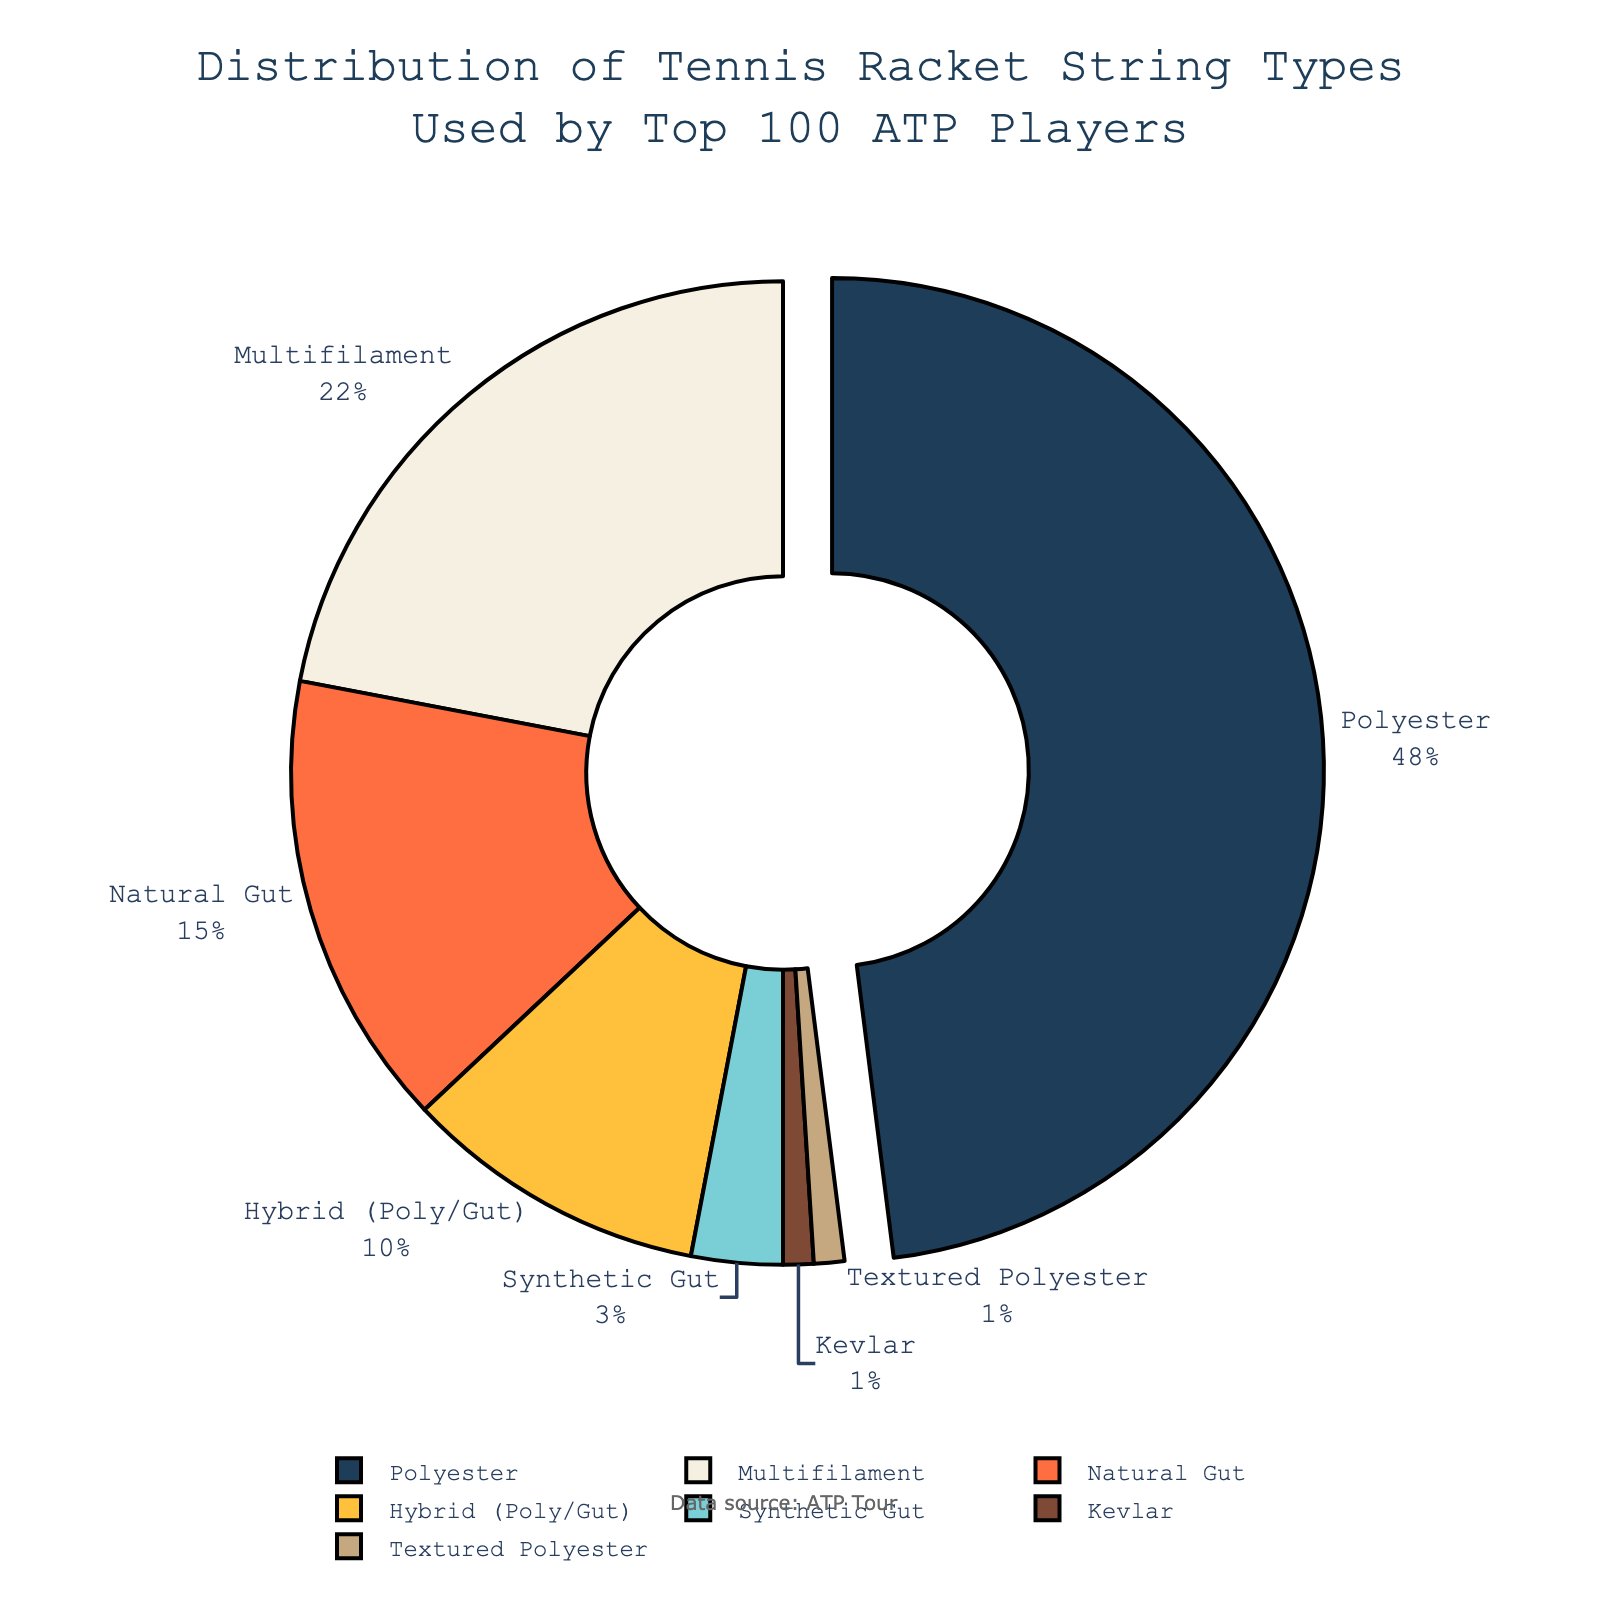Which string type has the highest percentage usage? The pie chart highlights the segment with the highest percentage usage. The chart also pulls this segment outward to make it more noticeable. The label shows that Polyester has the highest percentage at 48%.
Answer: Polyester What is the combined percentage of players using Hybrid and Synthetic Gut strings? To find the combined percentage, we add the percentage of players using Hybrid (10%) and the percentage using Synthetic Gut (3%). Therefore, 10 + 3 = 13%.
Answer: 13% How much more popular is Natural Gut compared to Synthetic Gut? To determine the difference in popularity, subtract the percentage of players using Synthetic Gut (3%) from those using Natural Gut (15%). Thus, 15 - 3 = 12%.
Answer: 12% Which string type has the least usage among top 100 ATP players? The pie chart shows the smallest segment labelled Textured Polyester, indicating it has the least usage at 1%.
Answer: Textured Polyester Compare the usage of Multifilament and Polyester strings: which one is more popular, and by how much in percentage points? Polyester is more popular than Multifilament. To find the difference, subtract the percentage of Multifilament (22%) from Polyester (48%). Thus, 48 - 22 = 26%.
Answer: Polyester, by 26% What is the total percentage of players using strings other than Polyester? Sum all the percentages except for Polyester’s 48%: 22% (Multifilament) + 15% (Natural Gut) + 10% (Hybrid) + 3% (Synthetic Gut) + 1% (Kevlar) + 1% (Textured Polyester) = 52%.
Answer: 52% If you combine the usage of Natural Gut and Kevlar, which other string type would this combination roughly equal in percentage? Sum the percentages of Natural Gut (15%) and Kevlar (1%) to get 16%. This is closest to Multifilament’s percentage (22%) but less than it.
Answer: Multifilament (as a close comparison) What percentage of players use either Natural Gut or Hybrid strings? Add the percentage of players using Natural Gut (15%) with those using Hybrid (10%). Hence, 15 + 10 = 25%.
Answer: 25% What is the difference between the usage percentages of Multifilament and Hybrid strings? Subtract the percentage of Hybrid (10%) from Multifilament (22%) resulting in 22 - 10 = 12%.
Answer: 12% What percentage of players uses strings that are not made of synthetic materials (Polyester, Multifilament, Synthetic Gut, Kevlar, Textured Polyester)? The non-synthetic strings are Natural Gut (15%) and Hybrid (which contains natural gut, 10%). So, 15% + 10% = 25%.
Answer: 25% 